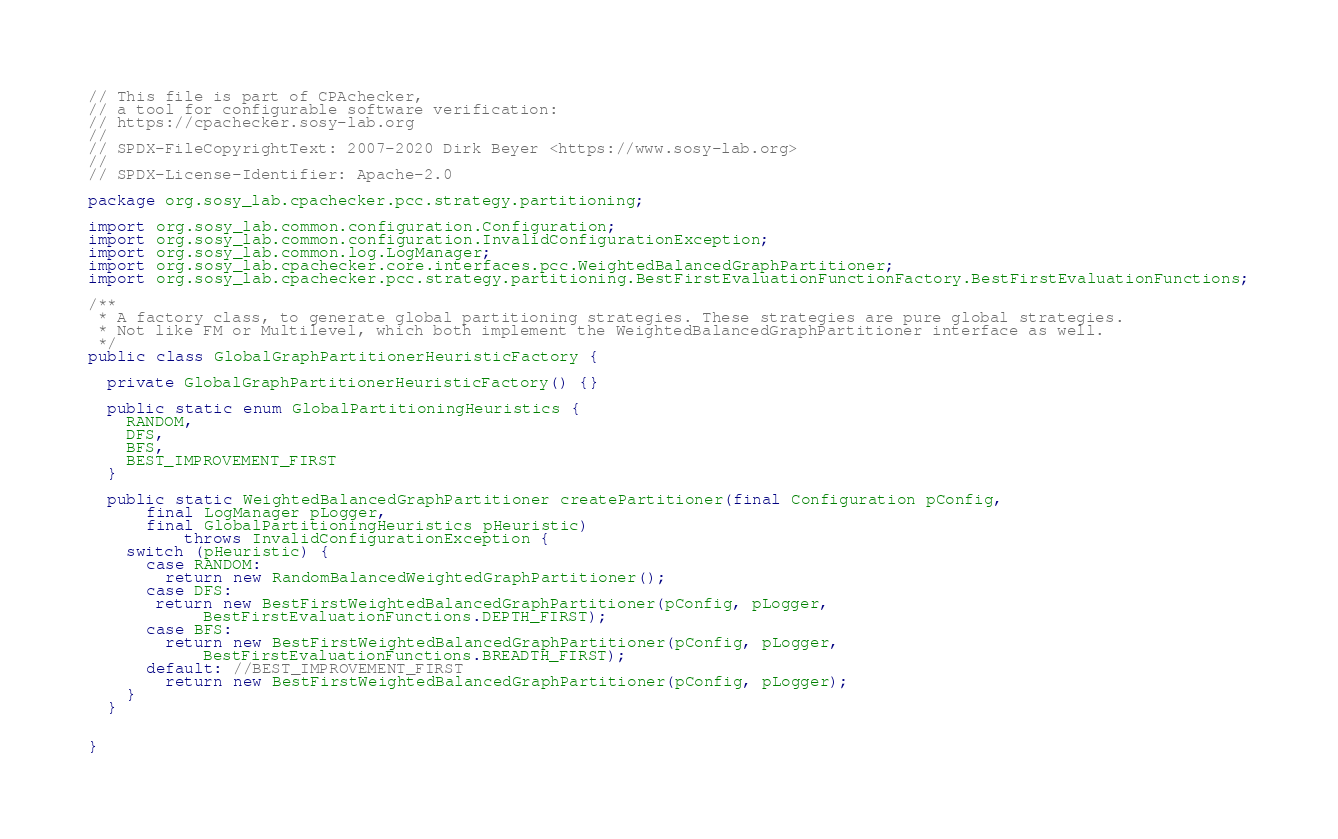Convert code to text. <code><loc_0><loc_0><loc_500><loc_500><_Java_>// This file is part of CPAchecker,
// a tool for configurable software verification:
// https://cpachecker.sosy-lab.org
//
// SPDX-FileCopyrightText: 2007-2020 Dirk Beyer <https://www.sosy-lab.org>
//
// SPDX-License-Identifier: Apache-2.0

package org.sosy_lab.cpachecker.pcc.strategy.partitioning;

import org.sosy_lab.common.configuration.Configuration;
import org.sosy_lab.common.configuration.InvalidConfigurationException;
import org.sosy_lab.common.log.LogManager;
import org.sosy_lab.cpachecker.core.interfaces.pcc.WeightedBalancedGraphPartitioner;
import org.sosy_lab.cpachecker.pcc.strategy.partitioning.BestFirstEvaluationFunctionFactory.BestFirstEvaluationFunctions;

/**
 * A factory class, to generate global partitioning strategies. These strategies are pure global strategies.
 * Not like FM or Multilevel, which both implement the WeightedBalancedGraphPartitioner interface as well.
 */
public class GlobalGraphPartitionerHeuristicFactory {

  private GlobalGraphPartitionerHeuristicFactory() {}

  public static enum GlobalPartitioningHeuristics {
    RANDOM,
    DFS,
    BFS,
    BEST_IMPROVEMENT_FIRST
  }

  public static WeightedBalancedGraphPartitioner createPartitioner(final Configuration pConfig,
      final LogManager pLogger,
      final GlobalPartitioningHeuristics pHeuristic)
          throws InvalidConfigurationException {
    switch (pHeuristic) {
      case RANDOM:
        return new RandomBalancedWeightedGraphPartitioner();
      case DFS:
       return new BestFirstWeightedBalancedGraphPartitioner(pConfig, pLogger,
            BestFirstEvaluationFunctions.DEPTH_FIRST);
      case BFS:
        return new BestFirstWeightedBalancedGraphPartitioner(pConfig, pLogger,
            BestFirstEvaluationFunctions.BREADTH_FIRST);
      default: //BEST_IMPROVEMENT_FIRST
        return new BestFirstWeightedBalancedGraphPartitioner(pConfig, pLogger);
    }
  }


}
</code> 